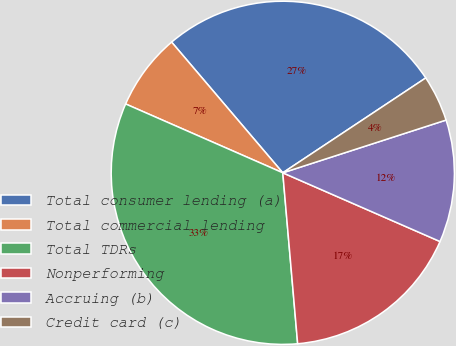Convert chart to OTSL. <chart><loc_0><loc_0><loc_500><loc_500><pie_chart><fcel>Total consumer lending (a)<fcel>Total commercial lending<fcel>Total TDRs<fcel>Nonperforming<fcel>Accruing (b)<fcel>Credit card (c)<nl><fcel>26.89%<fcel>7.21%<fcel>32.95%<fcel>17.06%<fcel>11.53%<fcel>4.35%<nl></chart> 